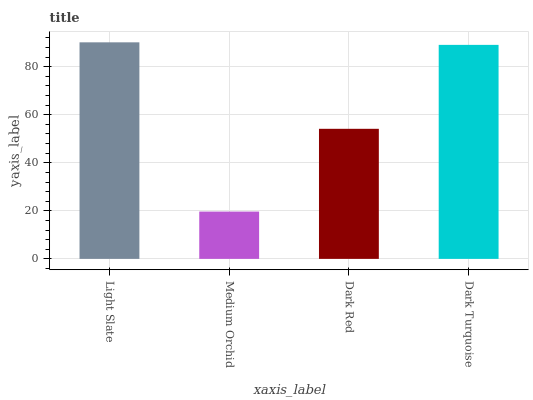Is Dark Red the minimum?
Answer yes or no. No. Is Dark Red the maximum?
Answer yes or no. No. Is Dark Red greater than Medium Orchid?
Answer yes or no. Yes. Is Medium Orchid less than Dark Red?
Answer yes or no. Yes. Is Medium Orchid greater than Dark Red?
Answer yes or no. No. Is Dark Red less than Medium Orchid?
Answer yes or no. No. Is Dark Turquoise the high median?
Answer yes or no. Yes. Is Dark Red the low median?
Answer yes or no. Yes. Is Dark Red the high median?
Answer yes or no. No. Is Light Slate the low median?
Answer yes or no. No. 